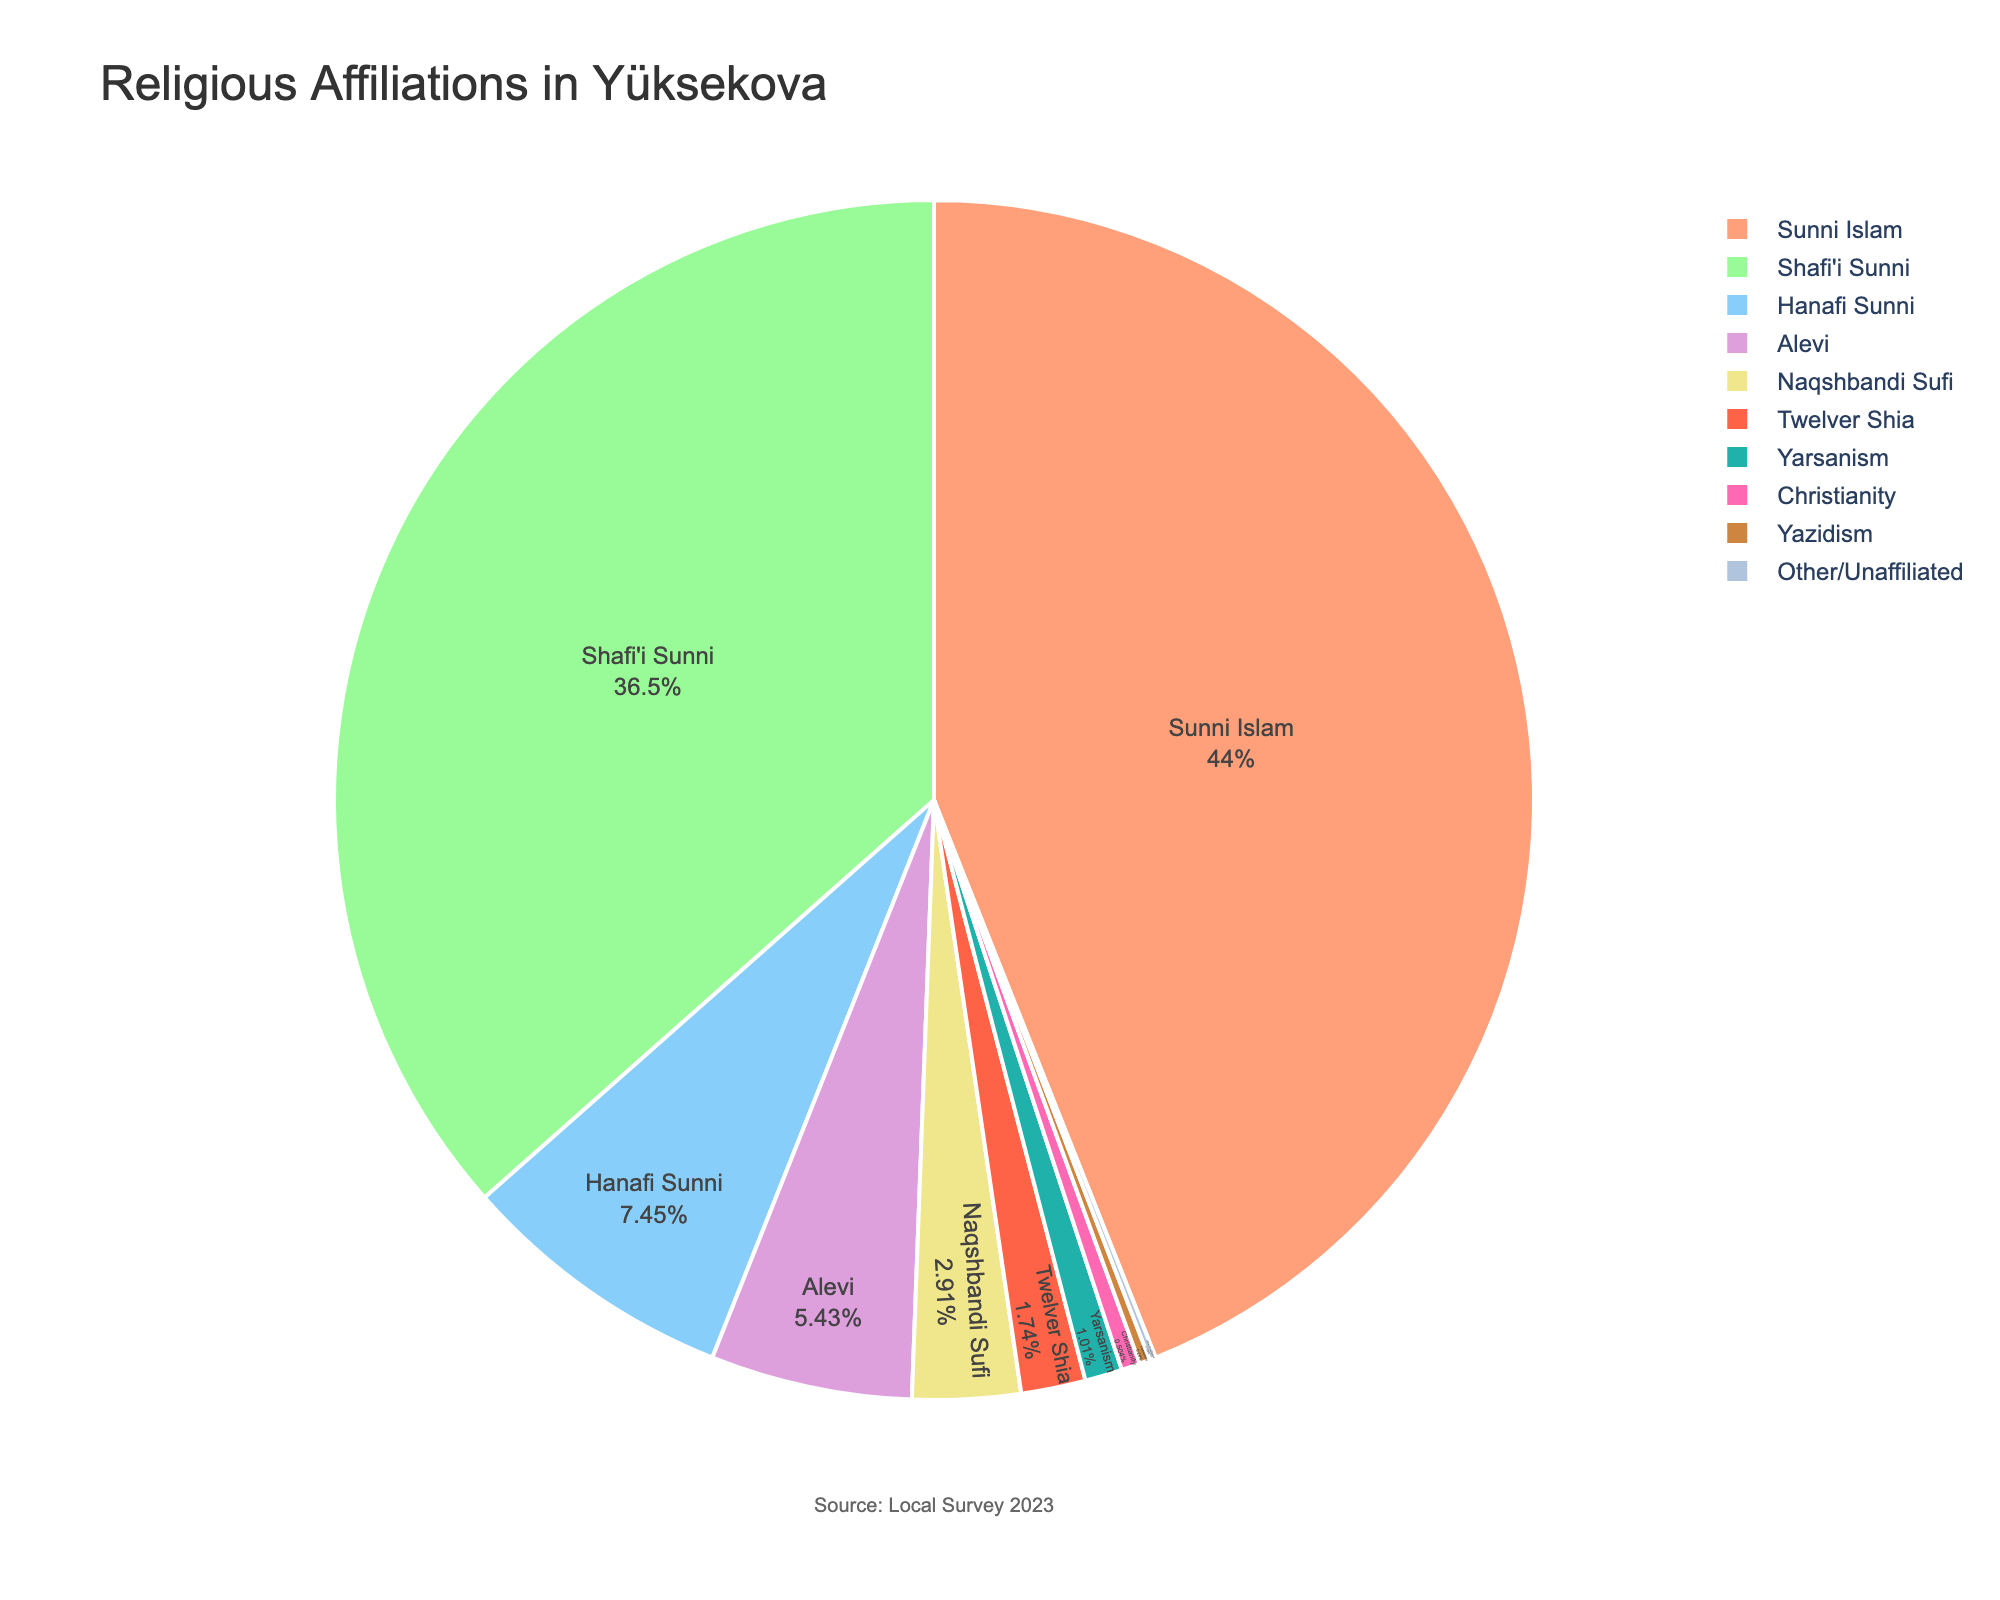What is the most prevalent religious affiliation in Yüksekova? The religion with the highest percentage is Sunni Islam, which can be observed from the pie chart. It covers the largest portion of the chart.
Answer: Sunni Islam What is the combined percentage of Sunni Islam (including Shafi'i and Hanafi)? To find the combined percentage, sum the percentages of Shafi'i Sunni (65.2) and Hanafi Sunni (13.3). 65.2 + 13.3 = 78.5%
Answer: 78.5% Which religion has the smallest affiliation in Yüksekova? By looking at the smallest segment in the pie chart, it is clear that "Other/Unaffiliated" has the smallest percentage at 0.3%.
Answer: Other/Unaffiliated How does the percentage of Alevi compare to that of Naqshbandi Sufi? Alevi has a percentage of 9.7%. Naqshbandi Sufi has a percentage of 5.2%. 9.7% - 5.2% = 4.5%, meaning Alevi is 4.5% higher.
Answer: Alevi is higher by 4.5% Which segment of the pie chart is colored in blue? By observing the color scheme used in the pie chart, the one corresponding to a shade of blue represents Shafi'i Sunni.
Answer: Shafi'i Sunni What is the difference in percentage between Twelver Shia and Christianity? Twelver Shia has a percentage of 3.1%, and Christianity has 0.9%. 3.1% - 0.9% = 2.2%
Answer: 2.2% How do the affiliations of Yazidism and Yarsanism compare visually in the chart? Yazidism occupies a smaller segment than Yarsanism. Yazidism is at 0.5%, and Yarsanism is at 1.8%, evident by the larger segment represented by Yarsanism.
Answer: Yarsanism is larger What percentage of the population belongs to faiths other than those listed (Other/Unaffiliated)? The chart shows that "Other/Unaffiliated" accounts for 0.3% of the population.
Answer: 0.3% If you combine the percentages of Alevi and Christian populations, how does the result compare to the population of Hanafi Sunni? Alevi (9.7%) + Christianity (0.9%) = 10.6%. Hanafi Sunni is 13.3%. Subtract 10.6% from 13.3% = 2.7%, so Hanafi Sunni is 2.7% higher than the combined Alevi and Christian population.
Answer: Hanafi Sunni is higher by 2.7% What proportion of the population is affiliated with any form of Sufi Islam (Naqshbandi)? Naqshbandi Sufi has a percentage of 5.2% as represented in its segment of the pie chart.
Answer: 5.2% 